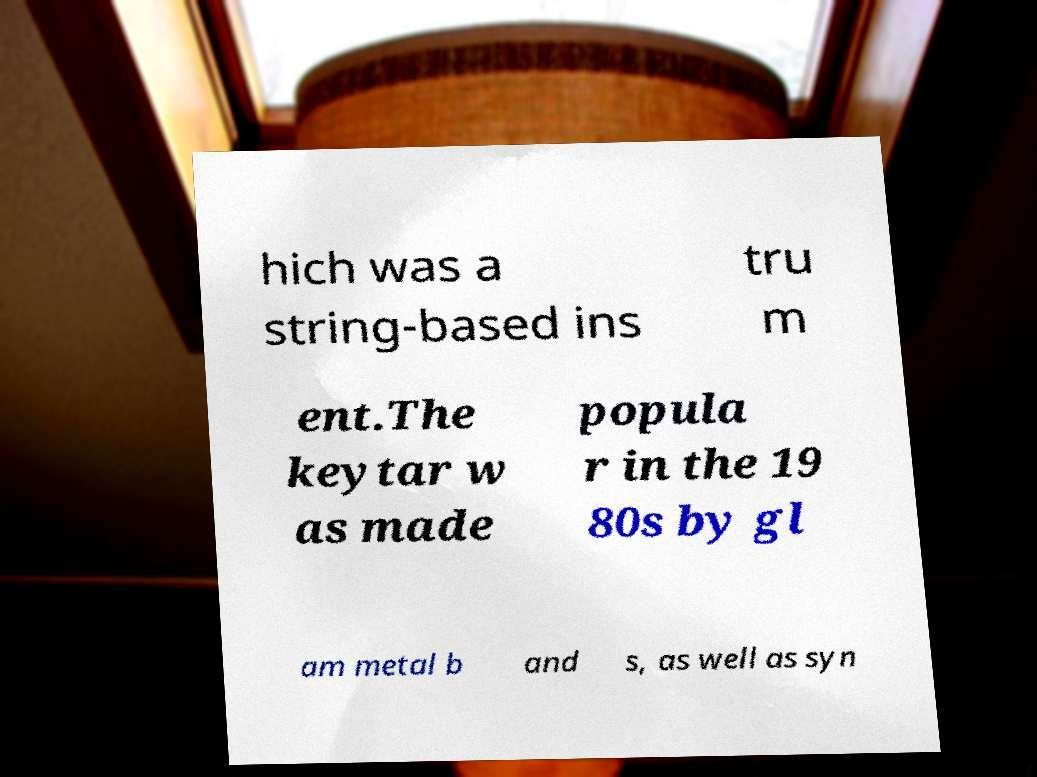Please identify and transcribe the text found in this image. hich was a string-based ins tru m ent.The keytar w as made popula r in the 19 80s by gl am metal b and s, as well as syn 